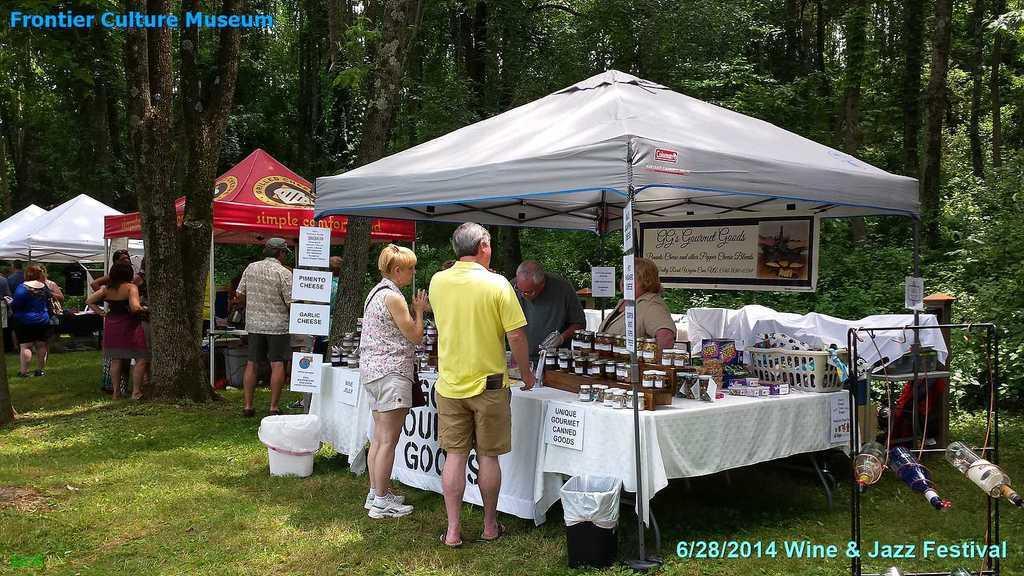Could you give a brief overview of what you see in this image? There are tents in different colors arranged on the grass on the ground. In the tents, there are persons, there are tables, on which, there are bottles and other objects. There is a white color bucket on the grass on the ground. In the background, there are plants and trees. 